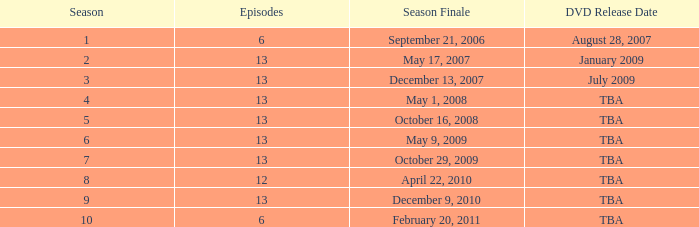On what date was the DVD released for the season with fewer than 13 episodes that aired before season 8? August 28, 2007. 